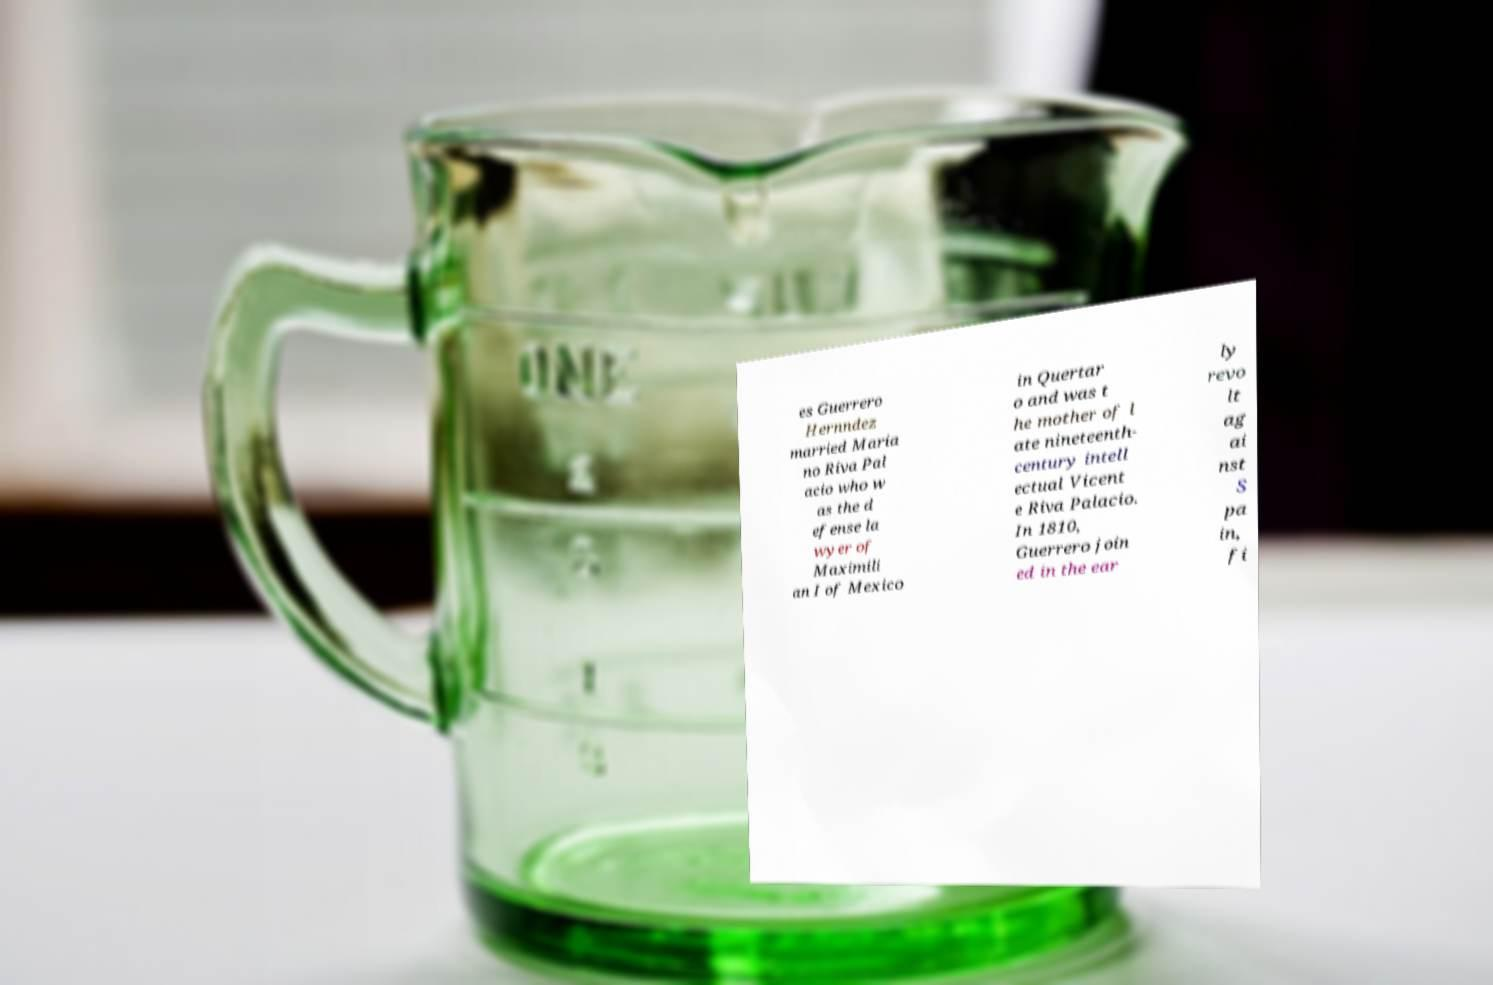Could you assist in decoding the text presented in this image and type it out clearly? es Guerrero Hernndez married Maria no Riva Pal acio who w as the d efense la wyer of Maximili an I of Mexico in Quertar o and was t he mother of l ate nineteenth- century intell ectual Vicent e Riva Palacio. In 1810, Guerrero join ed in the ear ly revo lt ag ai nst S pa in, fi 